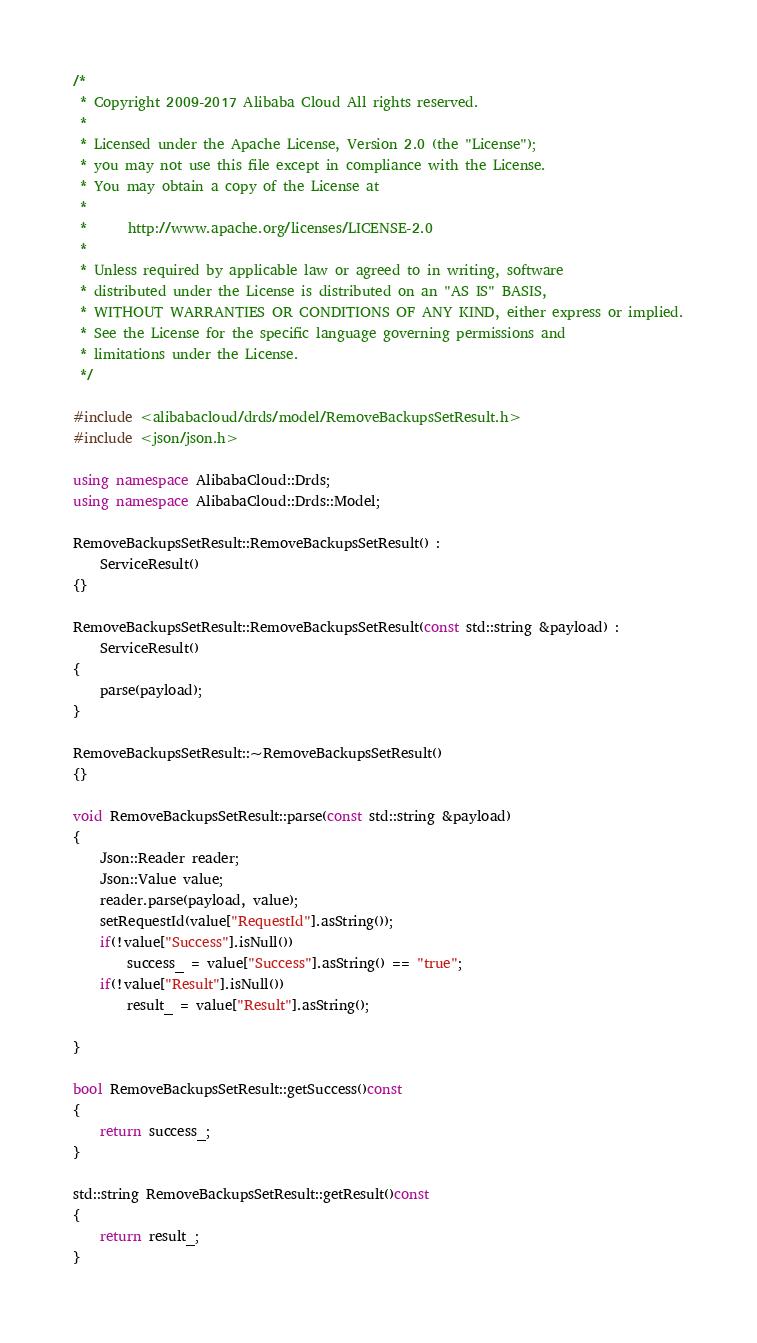Convert code to text. <code><loc_0><loc_0><loc_500><loc_500><_C++_>/*
 * Copyright 2009-2017 Alibaba Cloud All rights reserved.
 * 
 * Licensed under the Apache License, Version 2.0 (the "License");
 * you may not use this file except in compliance with the License.
 * You may obtain a copy of the License at
 * 
 *      http://www.apache.org/licenses/LICENSE-2.0
 * 
 * Unless required by applicable law or agreed to in writing, software
 * distributed under the License is distributed on an "AS IS" BASIS,
 * WITHOUT WARRANTIES OR CONDITIONS OF ANY KIND, either express or implied.
 * See the License for the specific language governing permissions and
 * limitations under the License.
 */

#include <alibabacloud/drds/model/RemoveBackupsSetResult.h>
#include <json/json.h>

using namespace AlibabaCloud::Drds;
using namespace AlibabaCloud::Drds::Model;

RemoveBackupsSetResult::RemoveBackupsSetResult() :
	ServiceResult()
{}

RemoveBackupsSetResult::RemoveBackupsSetResult(const std::string &payload) :
	ServiceResult()
{
	parse(payload);
}

RemoveBackupsSetResult::~RemoveBackupsSetResult()
{}

void RemoveBackupsSetResult::parse(const std::string &payload)
{
	Json::Reader reader;
	Json::Value value;
	reader.parse(payload, value);
	setRequestId(value["RequestId"].asString());
	if(!value["Success"].isNull())
		success_ = value["Success"].asString() == "true";
	if(!value["Result"].isNull())
		result_ = value["Result"].asString();

}

bool RemoveBackupsSetResult::getSuccess()const
{
	return success_;
}

std::string RemoveBackupsSetResult::getResult()const
{
	return result_;
}

</code> 